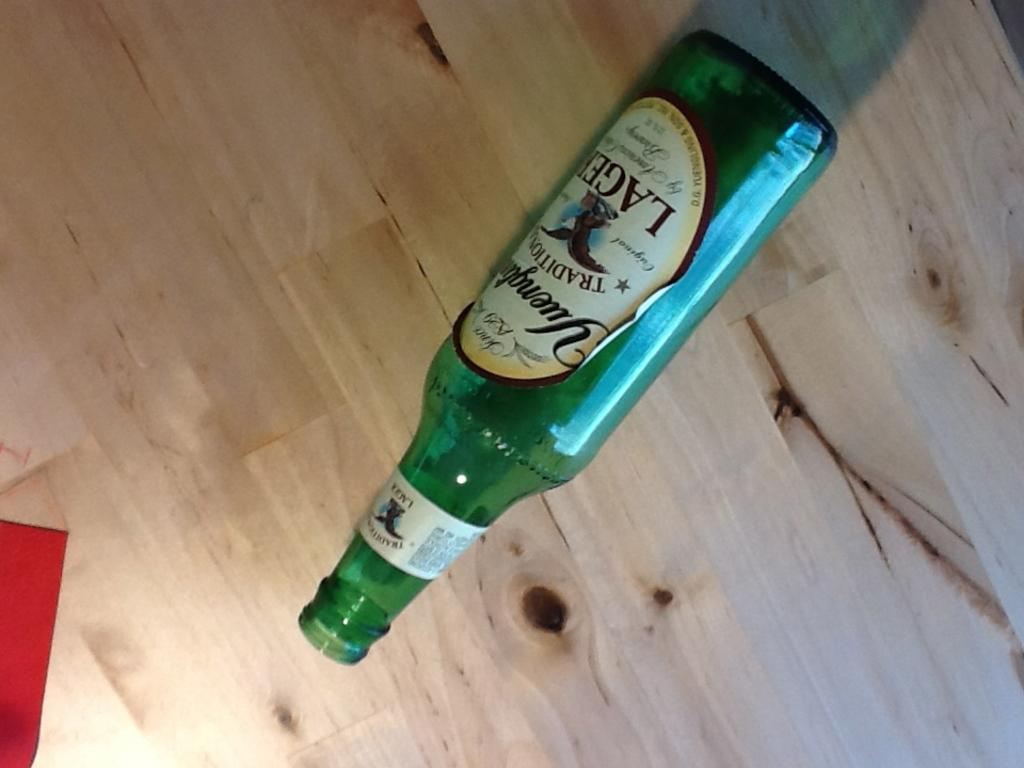<image>
Write a terse but informative summary of the picture. An empty bottle of Yuengling lager lays on its side. 